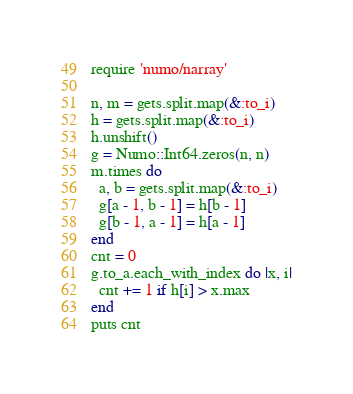<code> <loc_0><loc_0><loc_500><loc_500><_Ruby_>require 'numo/narray'

n, m = gets.split.map(&:to_i)
h = gets.split.map(&:to_i)
h.unshift()
g = Numo::Int64.zeros(n, n)
m.times do
  a, b = gets.split.map(&:to_i)
  g[a - 1, b - 1] = h[b - 1]
  g[b - 1, a - 1] = h[a - 1]
end
cnt = 0
g.to_a.each_with_index do |x, i|
  cnt += 1 if h[i] > x.max
end
puts cnt</code> 